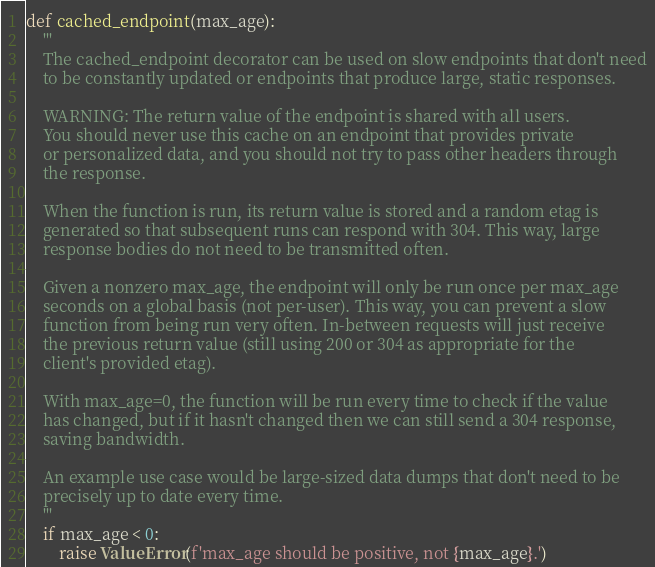Convert code to text. <code><loc_0><loc_0><loc_500><loc_500><_Python_>
def cached_endpoint(max_age):
    '''
    The cached_endpoint decorator can be used on slow endpoints that don't need
    to be constantly updated or endpoints that produce large, static responses.

    WARNING: The return value of the endpoint is shared with all users.
    You should never use this cache on an endpoint that provides private
    or personalized data, and you should not try to pass other headers through
    the response.

    When the function is run, its return value is stored and a random etag is
    generated so that subsequent runs can respond with 304. This way, large
    response bodies do not need to be transmitted often.

    Given a nonzero max_age, the endpoint will only be run once per max_age
    seconds on a global basis (not per-user). This way, you can prevent a slow
    function from being run very often. In-between requests will just receive
    the previous return value (still using 200 or 304 as appropriate for the
    client's provided etag).

    With max_age=0, the function will be run every time to check if the value
    has changed, but if it hasn't changed then we can still send a 304 response,
    saving bandwidth.

    An example use case would be large-sized data dumps that don't need to be
    precisely up to date every time.
    '''
    if max_age < 0:
        raise ValueError(f'max_age should be positive, not {max_age}.')
</code> 